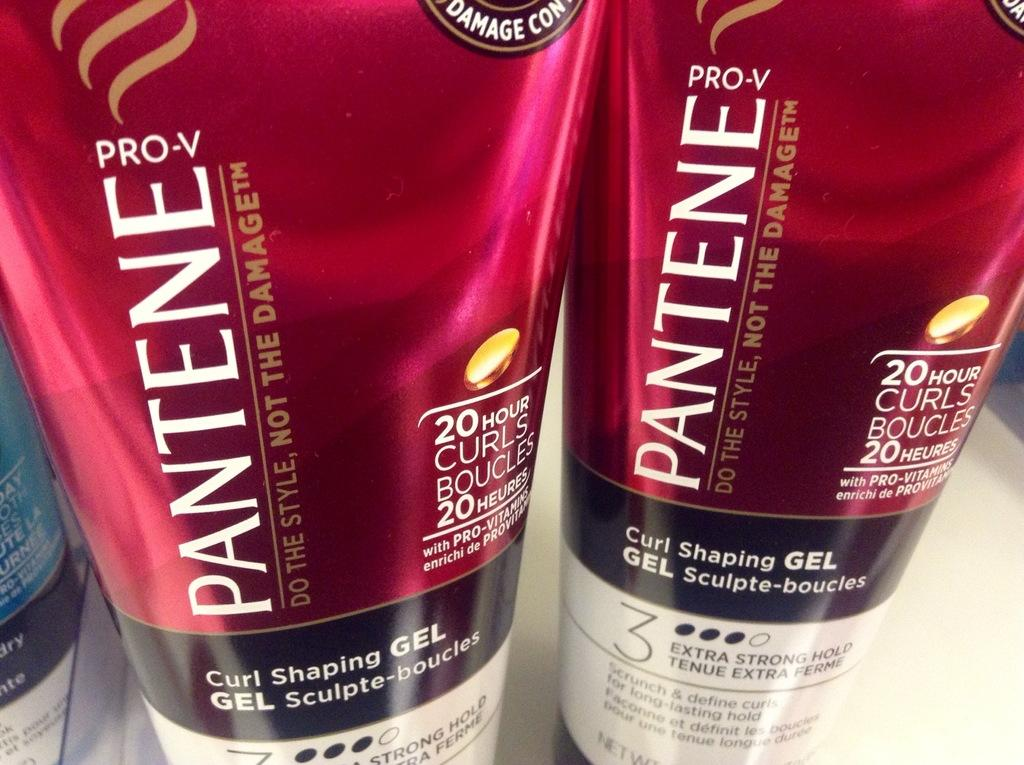Provide a one-sentence caption for the provided image. The tagline of the Pantene product is "Do the style, not the damage". 